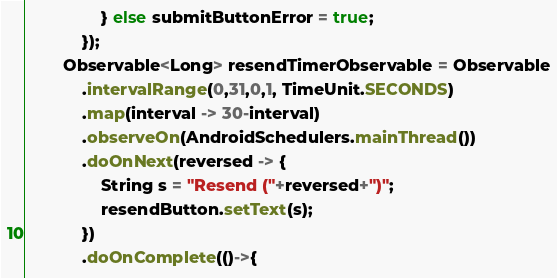<code> <loc_0><loc_0><loc_500><loc_500><_Java_>                } else submitButtonError = true;
            });
        Observable<Long> resendTimerObservable = Observable
            .intervalRange(0,31,0,1, TimeUnit.SECONDS)
            .map(interval -> 30-interval)
            .observeOn(AndroidSchedulers.mainThread())
            .doOnNext(reversed -> {
                String s = "Resend ("+reversed+")";
                resendButton.setText(s);
            })
            .doOnComplete(()->{</code> 